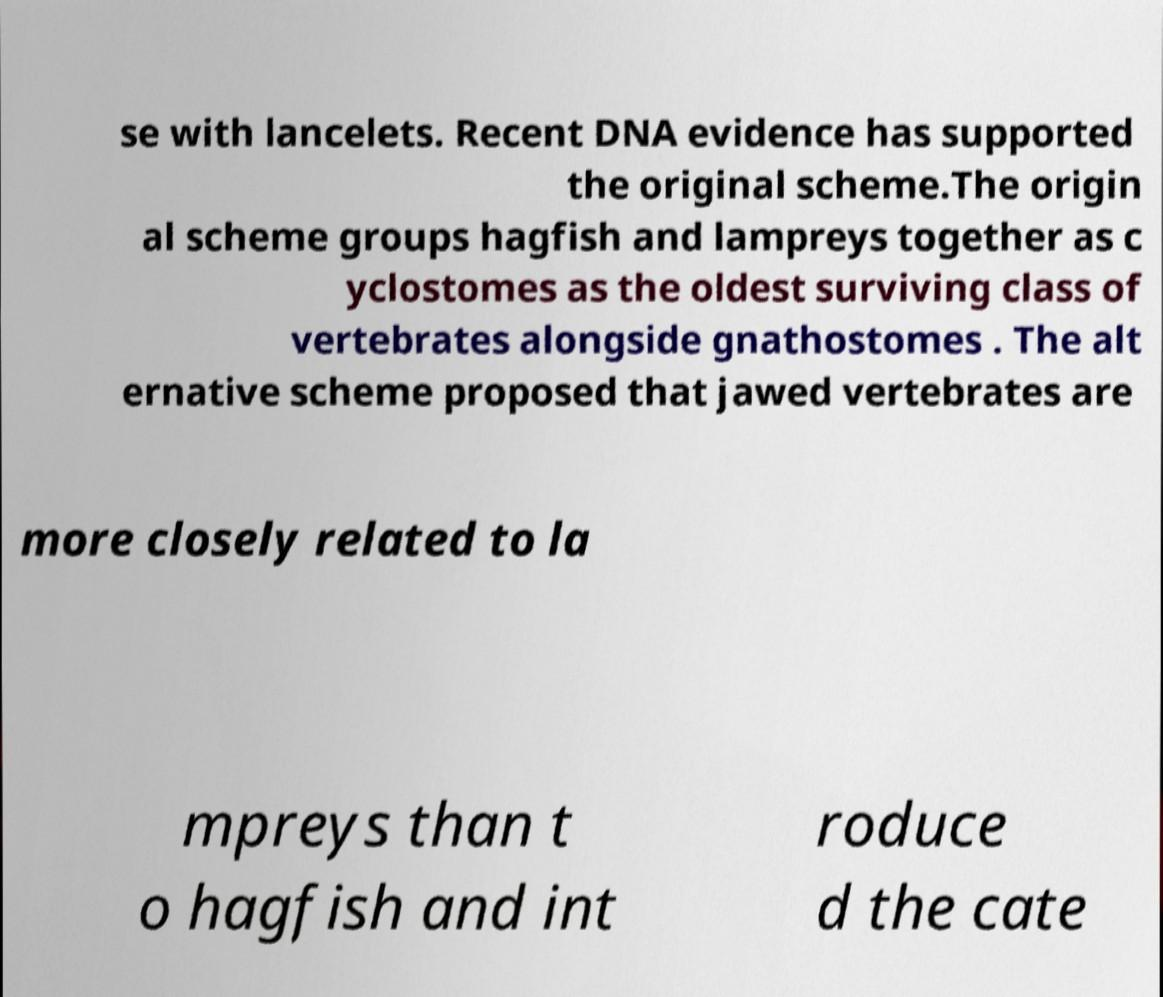Please identify and transcribe the text found in this image. se with lancelets. Recent DNA evidence has supported the original scheme.The origin al scheme groups hagfish and lampreys together as c yclostomes as the oldest surviving class of vertebrates alongside gnathostomes . The alt ernative scheme proposed that jawed vertebrates are more closely related to la mpreys than t o hagfish and int roduce d the cate 